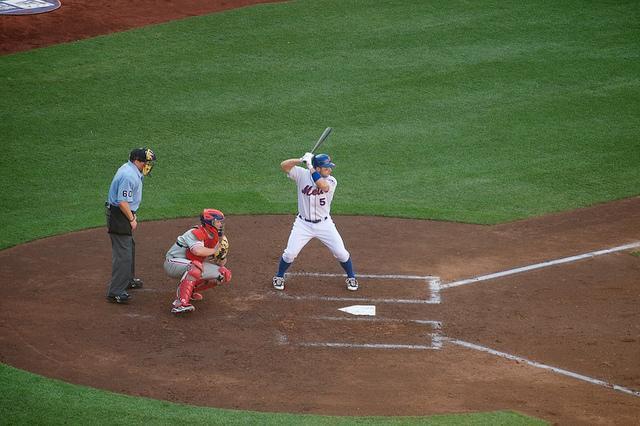How many people are there?
Give a very brief answer. 3. How many sinks are in this picture?
Give a very brief answer. 0. 